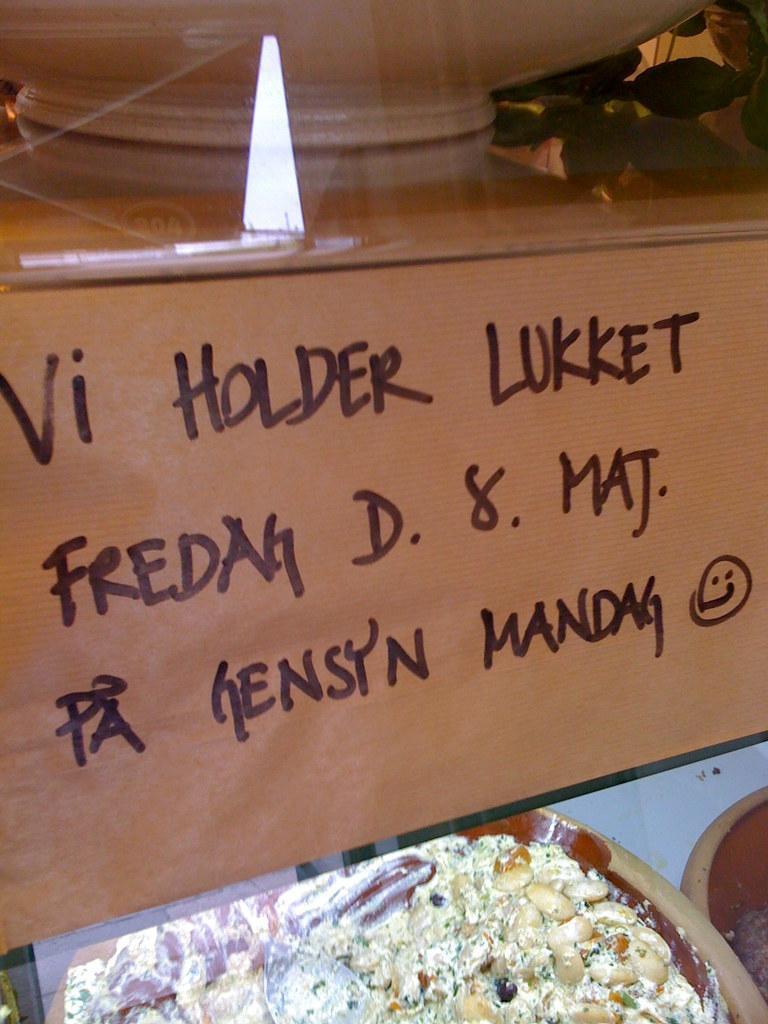Can you describe this image briefly? This picture shows couple of bowls with some food and we see a board with some text on it. 